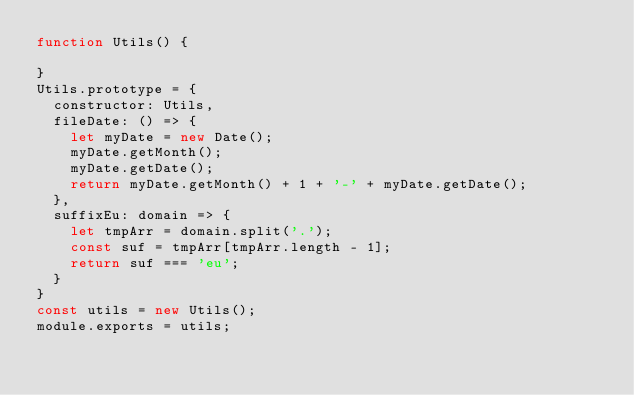<code> <loc_0><loc_0><loc_500><loc_500><_JavaScript_>function Utils() {

}
Utils.prototype = {
  constructor: Utils,
  fileDate: () => {
    let myDate = new Date();
    myDate.getMonth();
    myDate.getDate();
    return myDate.getMonth() + 1 + '-' + myDate.getDate();
  },
  suffixEu: domain => {
    let tmpArr = domain.split('.');
    const suf = tmpArr[tmpArr.length - 1];
    return suf === 'eu';
  }
}
const utils = new Utils();
module.exports = utils;
</code> 